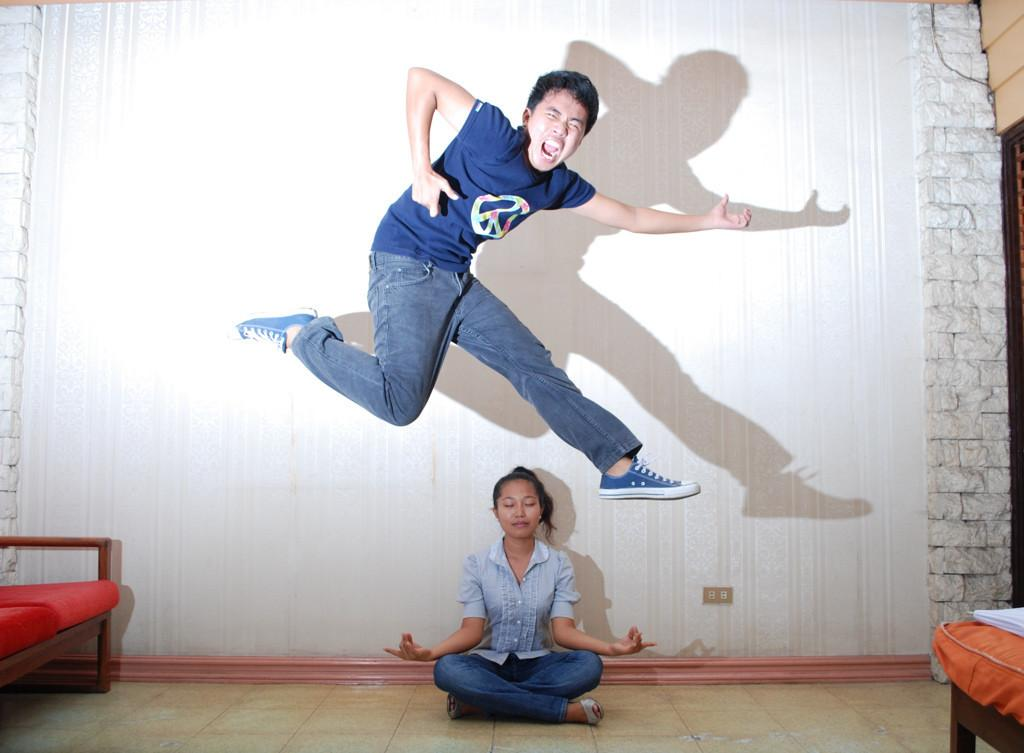What is the person on the floor doing in the image? The person on the floor is doing yoga. What is the other person in the image doing? The other person is jumping. What can be seen in the background of the image? There is a white wall in the background. Where is the sofa located in the image? The sofa is on the left side of the image. What type of shirt is the faucet wearing in the image? There is no faucet or shirt present in the image. How many bulbs are visible in the image? There are no bulbs present in the image. 